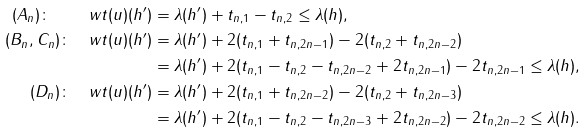Convert formula to latex. <formula><loc_0><loc_0><loc_500><loc_500>( A _ { n } ) \colon \quad w t ( u ) ( h ^ { \prime } ) & = \lambda ( h ^ { \prime } ) + t _ { n , 1 } - t _ { n , 2 } \leq \lambda ( h ) , \\ ( B _ { n } , C _ { n } ) \colon \quad w t ( u ) ( h ^ { \prime } ) & = \lambda ( h ^ { \prime } ) + 2 ( t _ { n , 1 } + t _ { n , 2 n - 1 } ) - 2 ( t _ { n , 2 } + t _ { n , 2 n - 2 } ) \\ & = \lambda ( h ^ { \prime } ) + 2 ( t _ { n , 1 } - t _ { n , 2 } - t _ { n , 2 n - 2 } + 2 t _ { n , 2 n - 1 } ) - 2 t _ { n , 2 n - 1 } \leq \lambda ( h ) , \\ ( D _ { n } ) \colon \quad w t ( u ) ( h ^ { \prime } ) & = \lambda ( h ^ { \prime } ) + 2 ( t _ { n , 1 } + t _ { n , 2 n - 2 } ) - 2 ( t _ { n , 2 } + t _ { n , 2 n - 3 } ) \\ & = \lambda ( h ^ { \prime } ) + 2 ( t _ { n , 1 } - t _ { n , 2 } - t _ { n , 2 n - 3 } + 2 t _ { n , 2 n - 2 } ) - 2 t _ { n , 2 n - 2 } \leq \lambda ( h ) .</formula> 